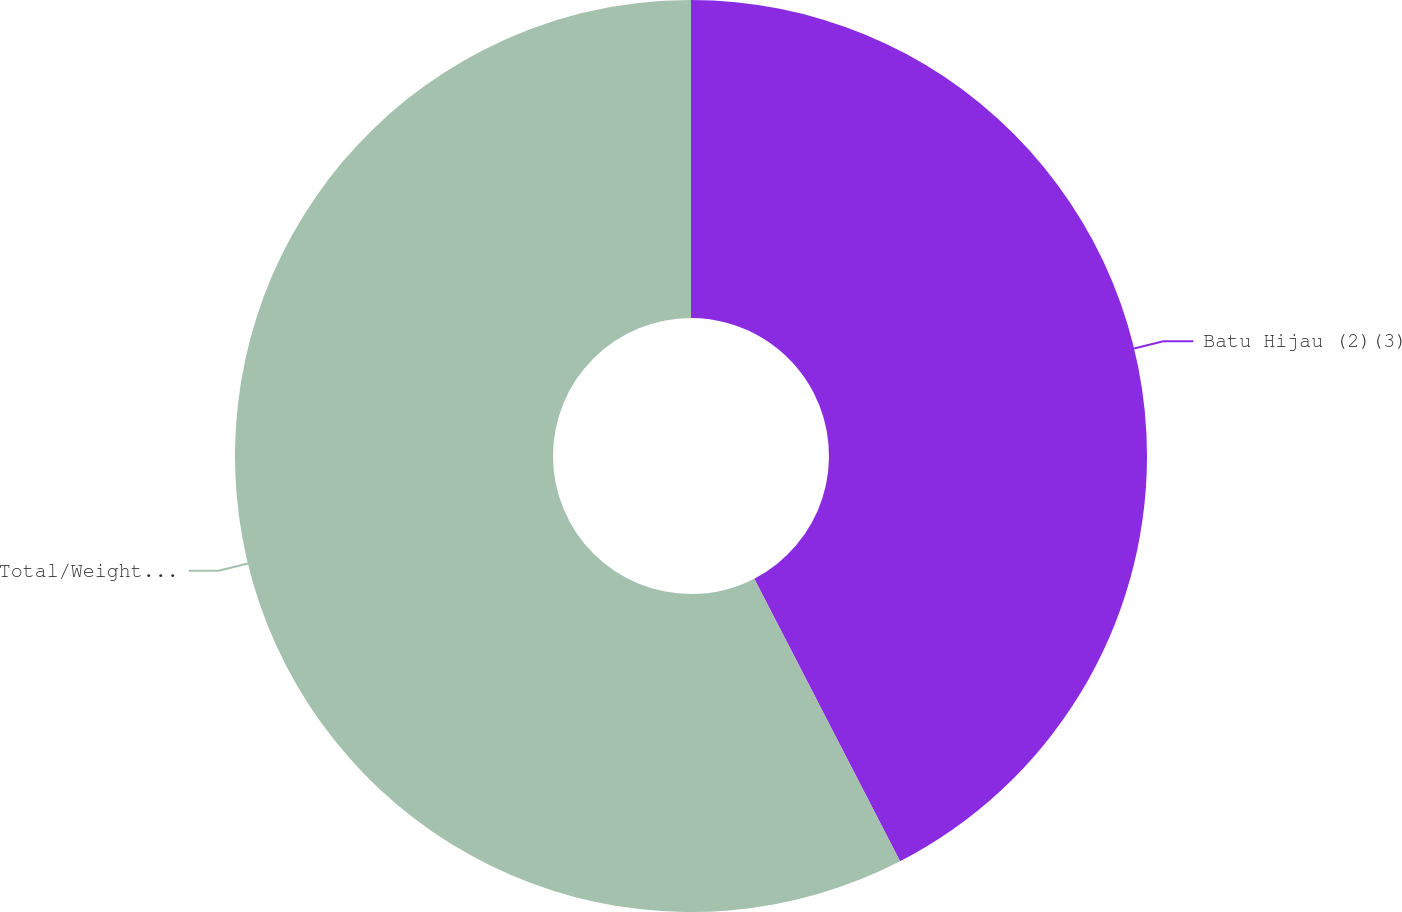Convert chart to OTSL. <chart><loc_0><loc_0><loc_500><loc_500><pie_chart><fcel>Batu Hijau (2)(3)<fcel>Total/Weighted-Average<nl><fcel>42.42%<fcel>57.58%<nl></chart> 